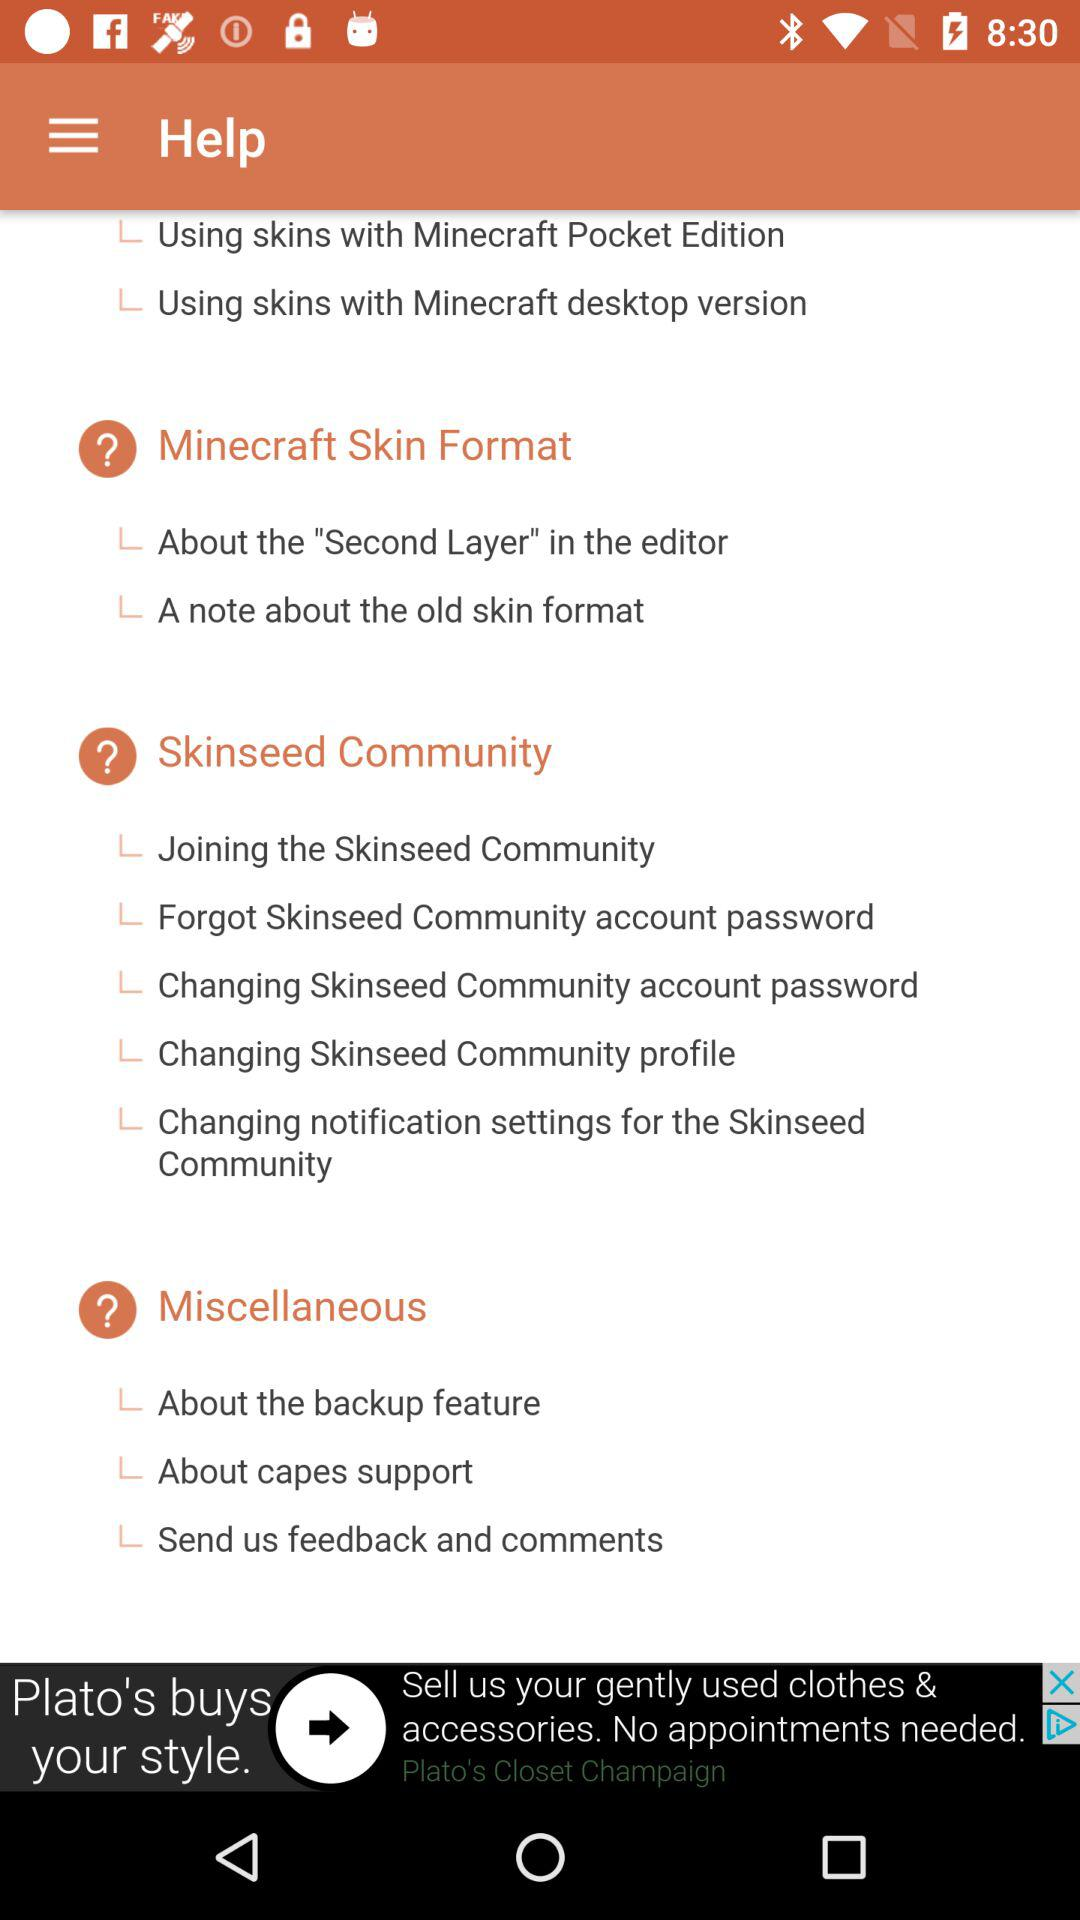How many sections are there in the help menu?
Answer the question using a single word or phrase. 4 